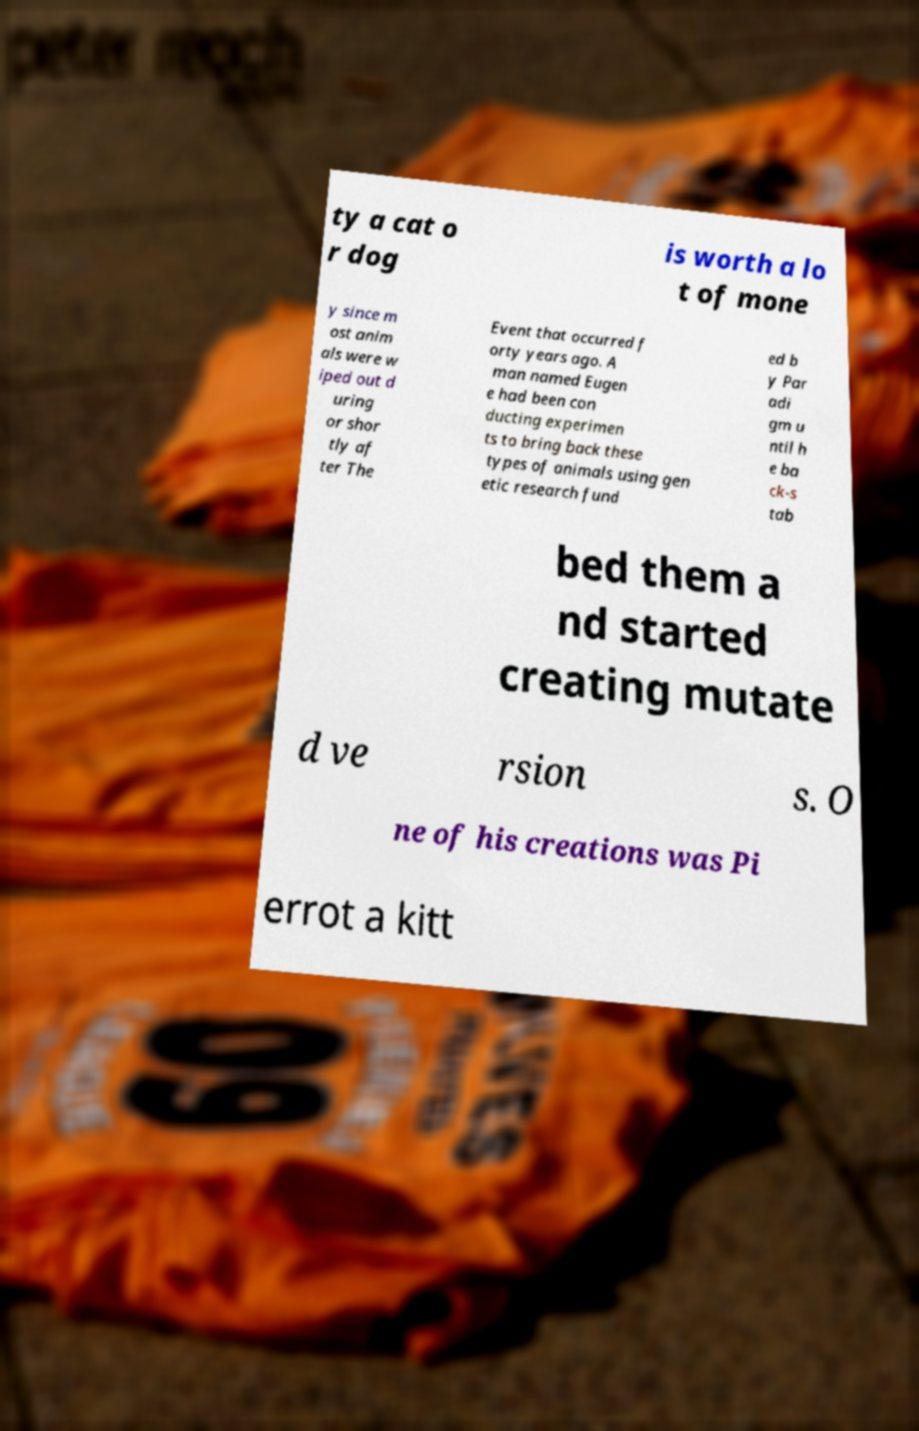For documentation purposes, I need the text within this image transcribed. Could you provide that? ty a cat o r dog is worth a lo t of mone y since m ost anim als were w iped out d uring or shor tly af ter The Event that occurred f orty years ago. A man named Eugen e had been con ducting experimen ts to bring back these types of animals using gen etic research fund ed b y Par adi gm u ntil h e ba ck-s tab bed them a nd started creating mutate d ve rsion s. O ne of his creations was Pi errot a kitt 